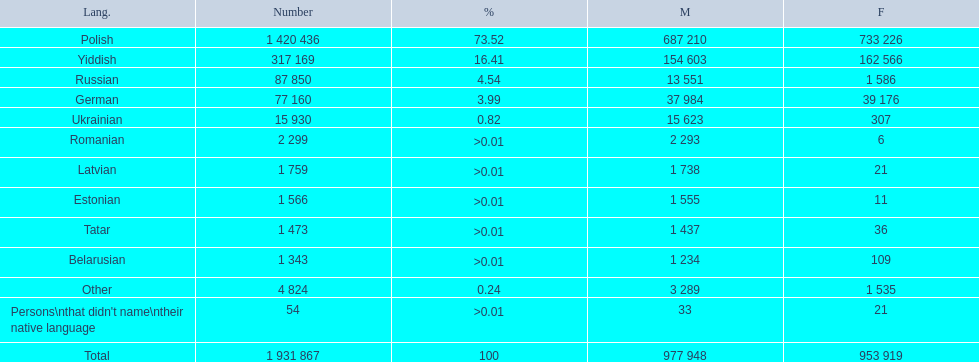How many languages are shown? Polish, Yiddish, Russian, German, Ukrainian, Romanian, Latvian, Estonian, Tatar, Belarusian, Other. What language is in third place? Russian. What language is the most spoken after that one? German. 